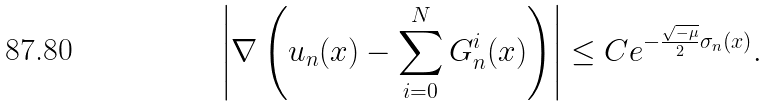<formula> <loc_0><loc_0><loc_500><loc_500>\left | \nabla \left ( u _ { n } ( x ) - \sum _ { i = 0 } ^ { N } G _ { n } ^ { i } ( x ) \right ) \right | \leq C e ^ { - \frac { \sqrt { - \mu } } { 2 } \sigma _ { n } ( x ) } .</formula> 